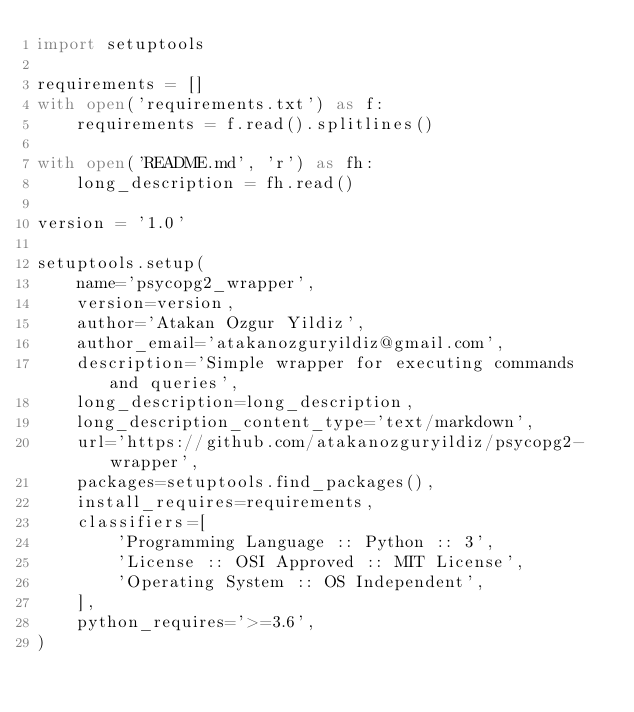<code> <loc_0><loc_0><loc_500><loc_500><_Python_>import setuptools

requirements = []
with open('requirements.txt') as f:
    requirements = f.read().splitlines()

with open('README.md', 'r') as fh:
    long_description = fh.read()

version = '1.0'

setuptools.setup(
    name='psycopg2_wrapper',
    version=version,
    author='Atakan Ozgur Yildiz',
    author_email='atakanozguryildiz@gmail.com',
    description='Simple wrapper for executing commands and queries',
    long_description=long_description,
    long_description_content_type='text/markdown',
    url='https://github.com/atakanozguryildiz/psycopg2-wrapper',
    packages=setuptools.find_packages(),
    install_requires=requirements,
    classifiers=[
        'Programming Language :: Python :: 3',
        'License :: OSI Approved :: MIT License',
        'Operating System :: OS Independent',
    ],
    python_requires='>=3.6',
)
</code> 